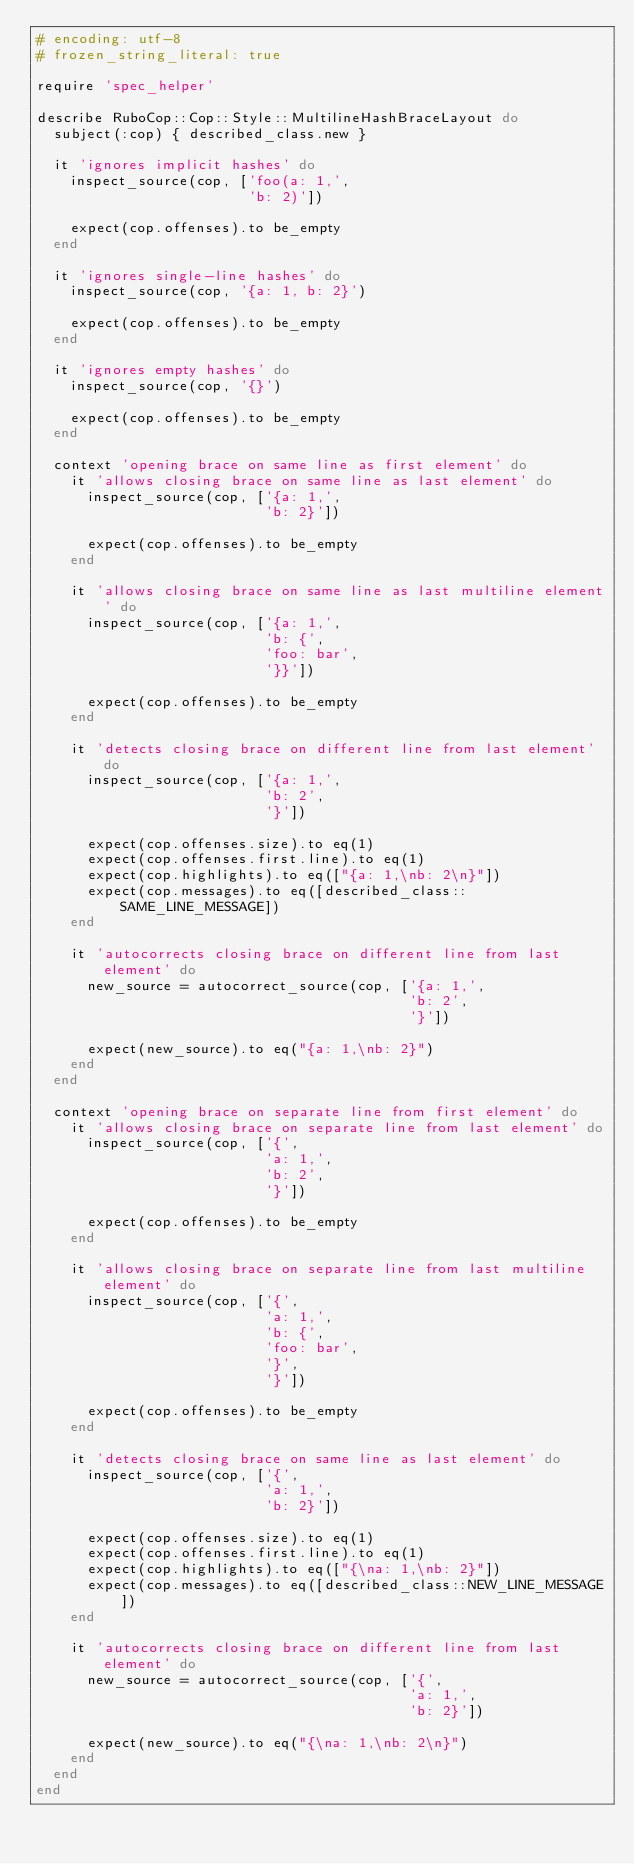<code> <loc_0><loc_0><loc_500><loc_500><_Ruby_># encoding: utf-8
# frozen_string_literal: true

require 'spec_helper'

describe RuboCop::Cop::Style::MultilineHashBraceLayout do
  subject(:cop) { described_class.new }

  it 'ignores implicit hashes' do
    inspect_source(cop, ['foo(a: 1,',
                         'b: 2)'])

    expect(cop.offenses).to be_empty
  end

  it 'ignores single-line hashes' do
    inspect_source(cop, '{a: 1, b: 2}')

    expect(cop.offenses).to be_empty
  end

  it 'ignores empty hashes' do
    inspect_source(cop, '{}')

    expect(cop.offenses).to be_empty
  end

  context 'opening brace on same line as first element' do
    it 'allows closing brace on same line as last element' do
      inspect_source(cop, ['{a: 1,',
                           'b: 2}'])

      expect(cop.offenses).to be_empty
    end

    it 'allows closing brace on same line as last multiline element' do
      inspect_source(cop, ['{a: 1,',
                           'b: {',
                           'foo: bar',
                           '}}'])

      expect(cop.offenses).to be_empty
    end

    it 'detects closing brace on different line from last element' do
      inspect_source(cop, ['{a: 1,',
                           'b: 2',
                           '}'])

      expect(cop.offenses.size).to eq(1)
      expect(cop.offenses.first.line).to eq(1)
      expect(cop.highlights).to eq(["{a: 1,\nb: 2\n}"])
      expect(cop.messages).to eq([described_class::SAME_LINE_MESSAGE])
    end

    it 'autocorrects closing brace on different line from last element' do
      new_source = autocorrect_source(cop, ['{a: 1,',
                                            'b: 2',
                                            '}'])

      expect(new_source).to eq("{a: 1,\nb: 2}")
    end
  end

  context 'opening brace on separate line from first element' do
    it 'allows closing brace on separate line from last element' do
      inspect_source(cop, ['{',
                           'a: 1,',
                           'b: 2',
                           '}'])

      expect(cop.offenses).to be_empty
    end

    it 'allows closing brace on separate line from last multiline element' do
      inspect_source(cop, ['{',
                           'a: 1,',
                           'b: {',
                           'foo: bar',
                           '}',
                           '}'])

      expect(cop.offenses).to be_empty
    end

    it 'detects closing brace on same line as last element' do
      inspect_source(cop, ['{',
                           'a: 1,',
                           'b: 2}'])

      expect(cop.offenses.size).to eq(1)
      expect(cop.offenses.first.line).to eq(1)
      expect(cop.highlights).to eq(["{\na: 1,\nb: 2}"])
      expect(cop.messages).to eq([described_class::NEW_LINE_MESSAGE])
    end

    it 'autocorrects closing brace on different line from last element' do
      new_source = autocorrect_source(cop, ['{',
                                            'a: 1,',
                                            'b: 2}'])

      expect(new_source).to eq("{\na: 1,\nb: 2\n}")
    end
  end
end
</code> 